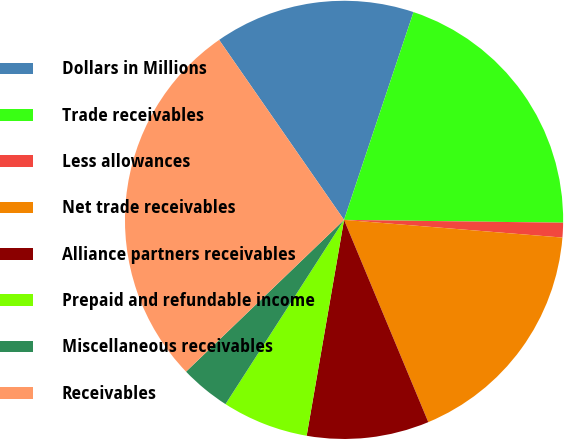<chart> <loc_0><loc_0><loc_500><loc_500><pie_chart><fcel>Dollars in Millions<fcel>Trade receivables<fcel>Less allowances<fcel>Net trade receivables<fcel>Alliance partners receivables<fcel>Prepaid and refundable income<fcel>Miscellaneous receivables<fcel>Receivables<nl><fcel>14.79%<fcel>20.07%<fcel>1.08%<fcel>17.43%<fcel>9.01%<fcel>6.37%<fcel>3.72%<fcel>27.52%<nl></chart> 